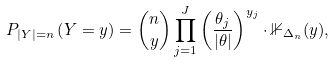Convert formula to latex. <formula><loc_0><loc_0><loc_500><loc_500>P _ { | Y | = n } \left ( Y = y \right ) = \binom { n } { y } \prod _ { j = 1 } ^ { J } \left ( \frac { \theta _ { j } } { | \theta | } \right ) ^ { y _ { j } } \cdot \mathbb { 1 } _ { \Delta _ { n } } ( y ) ,</formula> 